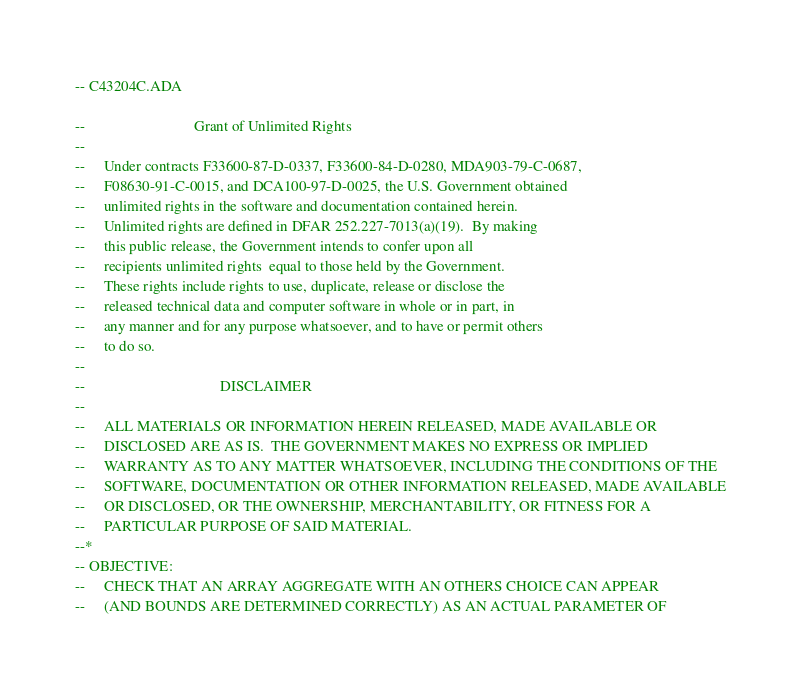<code> <loc_0><loc_0><loc_500><loc_500><_Ada_>-- C43204C.ADA

--                             Grant of Unlimited Rights
--
--     Under contracts F33600-87-D-0337, F33600-84-D-0280, MDA903-79-C-0687,
--     F08630-91-C-0015, and DCA100-97-D-0025, the U.S. Government obtained 
--     unlimited rights in the software and documentation contained herein.
--     Unlimited rights are defined in DFAR 252.227-7013(a)(19).  By making 
--     this public release, the Government intends to confer upon all 
--     recipients unlimited rights  equal to those held by the Government.  
--     These rights include rights to use, duplicate, release or disclose the 
--     released technical data and computer software in whole or in part, in 
--     any manner and for any purpose whatsoever, and to have or permit others 
--     to do so.
--
--                                    DISCLAIMER
--
--     ALL MATERIALS OR INFORMATION HEREIN RELEASED, MADE AVAILABLE OR
--     DISCLOSED ARE AS IS.  THE GOVERNMENT MAKES NO EXPRESS OR IMPLIED 
--     WARRANTY AS TO ANY MATTER WHATSOEVER, INCLUDING THE CONDITIONS OF THE
--     SOFTWARE, DOCUMENTATION OR OTHER INFORMATION RELEASED, MADE AVAILABLE 
--     OR DISCLOSED, OR THE OWNERSHIP, MERCHANTABILITY, OR FITNESS FOR A
--     PARTICULAR PURPOSE OF SAID MATERIAL.
--*
-- OBJECTIVE:
--     CHECK THAT AN ARRAY AGGREGATE WITH AN OTHERS CHOICE CAN APPEAR
--     (AND BOUNDS ARE DETERMINED CORRECTLY) AS AN ACTUAL PARAMETER OF</code> 